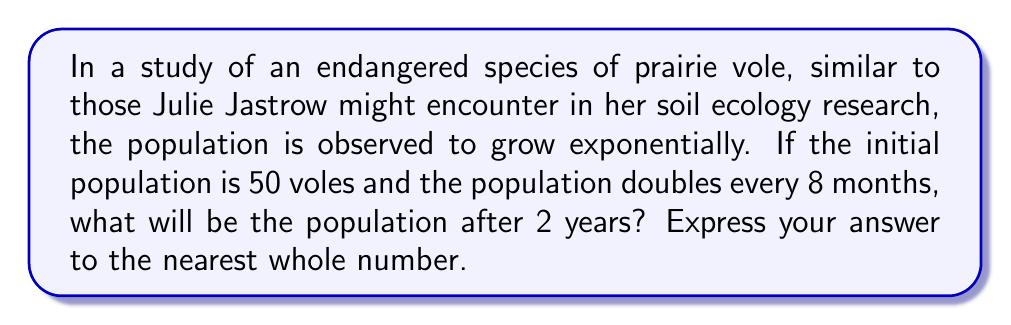Solve this math problem. Let's approach this step-by-step:

1) First, we need to identify the exponential growth model:
   $$P(t) = P_0 \cdot e^{rt}$$
   where $P(t)$ is the population at time $t$, $P_0$ is the initial population, $r$ is the growth rate, and $t$ is the time.

2) We're given that $P_0 = 50$ and the population doubles every 8 months.

3) To find $r$, we can use the doubling time formula:
   $$2 = e^{r \cdot 8}$$
   $$\ln(2) = 8r$$
   $$r = \frac{\ln(2)}{8} \approx 0.0866 \text{ per month}$$

4) Now, we need to calculate the population after 2 years, which is 24 months:
   $$P(24) = 50 \cdot e^{0.0866 \cdot 24}$$

5) Let's calculate this:
   $$P(24) = 50 \cdot e^{2.0784}$$
   $$P(24) = 50 \cdot 7.9909$$
   $$P(24) = 399.545$$

6) Rounding to the nearest whole number:
   $$P(24) \approx 400 \text{ voles}$$
Answer: 400 voles 